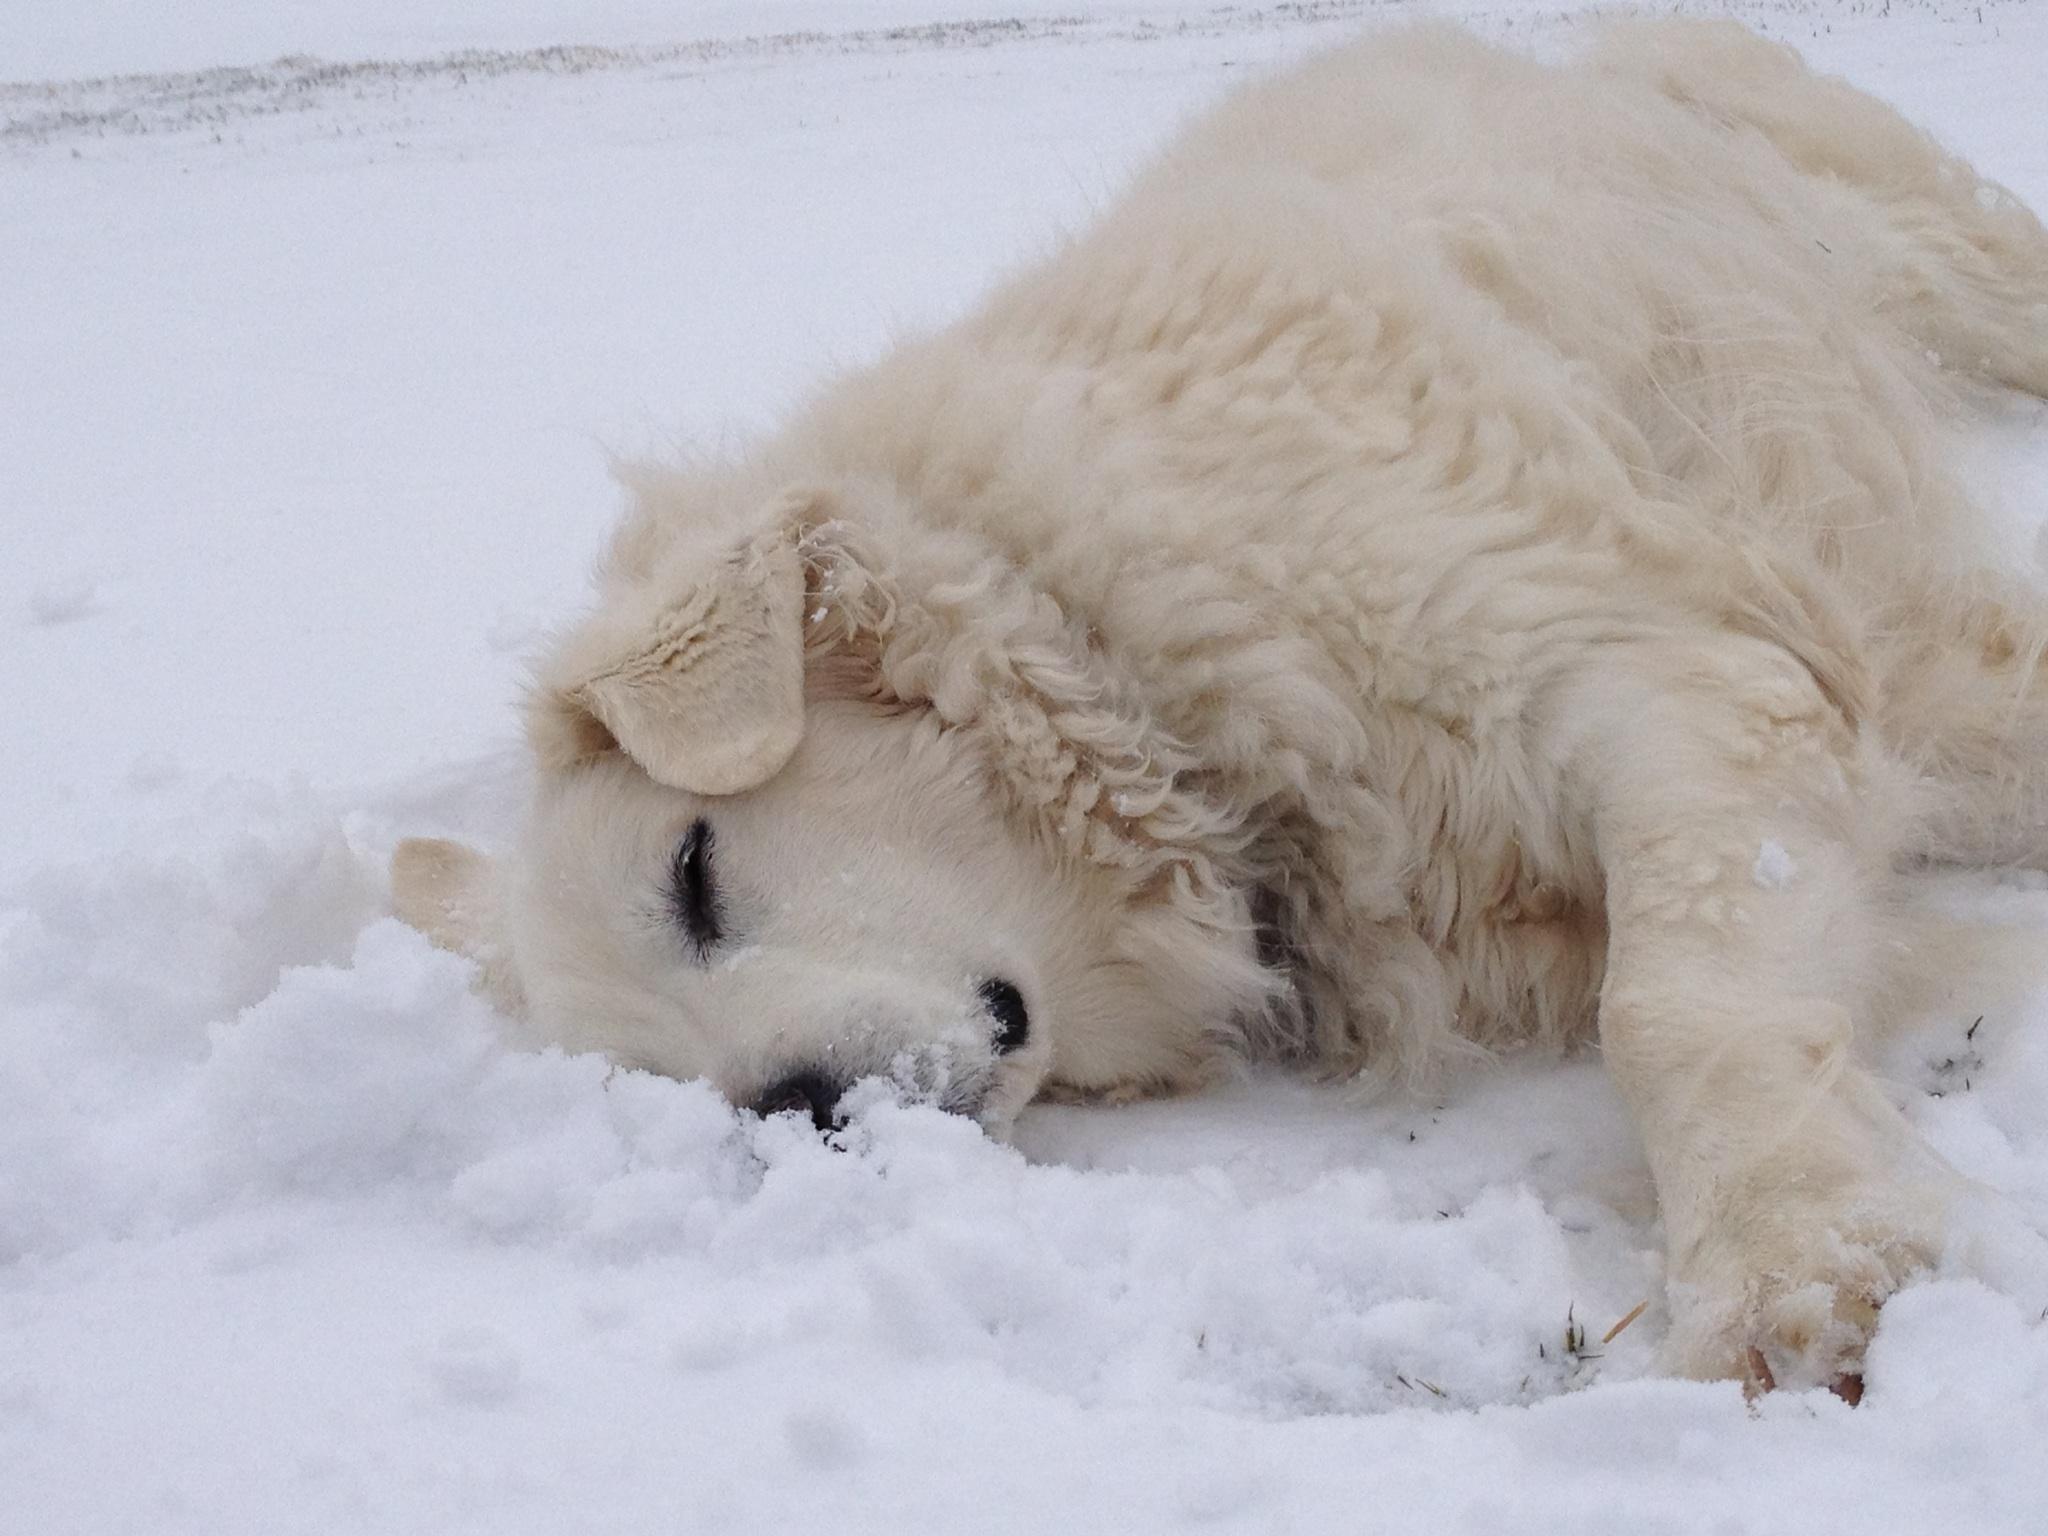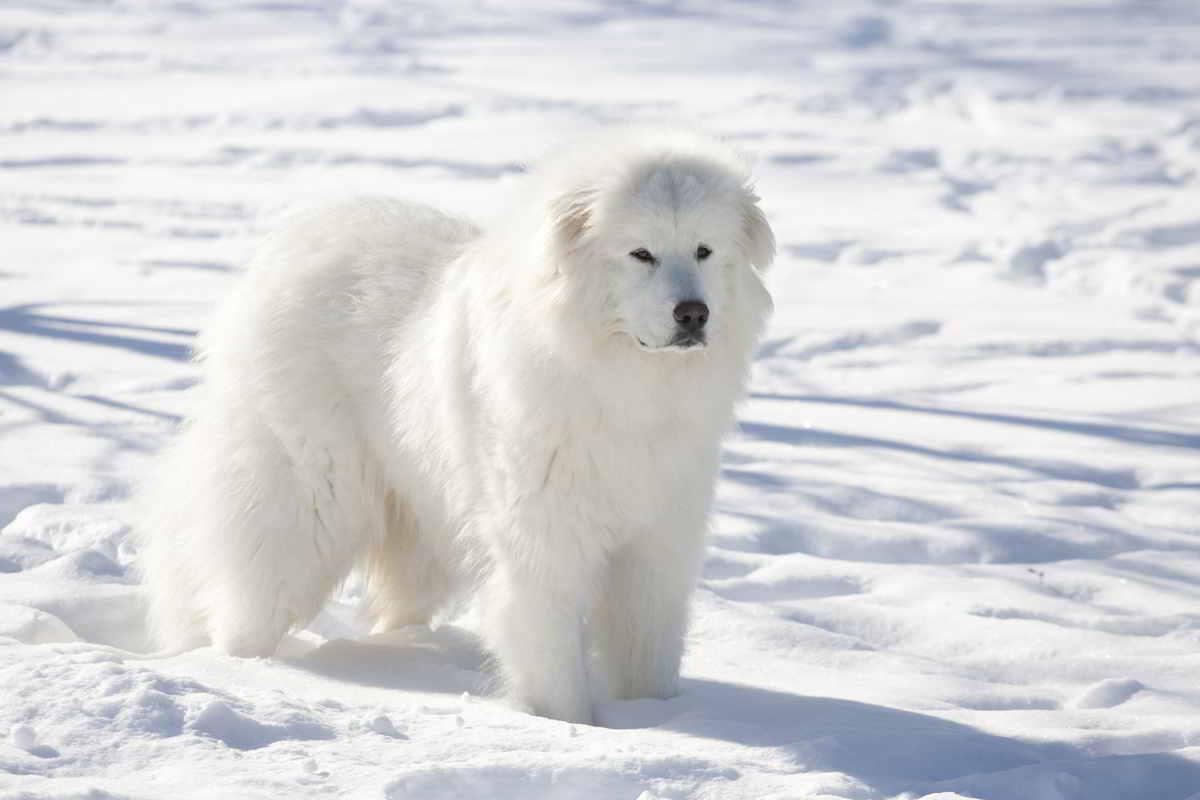The first image is the image on the left, the second image is the image on the right. Considering the images on both sides, is "A dogs lies down in the snow in the image on the left." valid? Answer yes or no. Yes. The first image is the image on the left, the second image is the image on the right. For the images displayed, is the sentence "Each image contains a single white dog, and at least one image shows a dog lying on the snow." factually correct? Answer yes or no. Yes. 